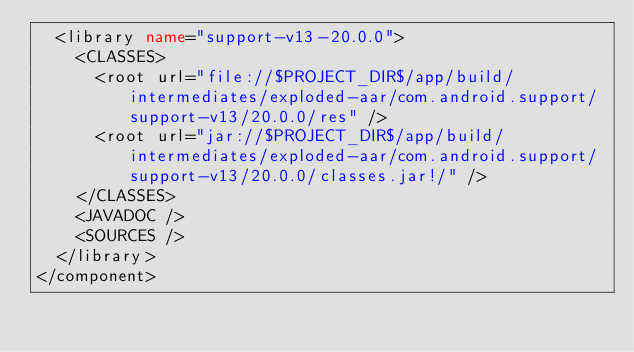Convert code to text. <code><loc_0><loc_0><loc_500><loc_500><_XML_>  <library name="support-v13-20.0.0">
    <CLASSES>
      <root url="file://$PROJECT_DIR$/app/build/intermediates/exploded-aar/com.android.support/support-v13/20.0.0/res" />
      <root url="jar://$PROJECT_DIR$/app/build/intermediates/exploded-aar/com.android.support/support-v13/20.0.0/classes.jar!/" />
    </CLASSES>
    <JAVADOC />
    <SOURCES />
  </library>
</component></code> 